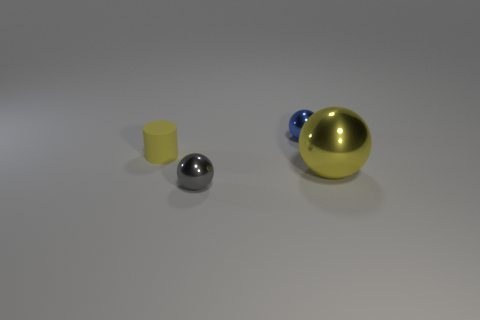Are there any other things that are the same shape as the large thing?
Offer a terse response. Yes. What is the color of the metallic thing that is to the right of the tiny thing to the right of the ball to the left of the tiny blue metal sphere?
Your answer should be very brief. Yellow. The object that is both left of the small blue sphere and behind the big yellow ball has what shape?
Your answer should be very brief. Cylinder. Are there any other things that have the same size as the blue object?
Keep it short and to the point. Yes. There is a metallic thing on the left side of the tiny metallic object that is behind the yellow ball; what is its color?
Your answer should be very brief. Gray. There is a yellow object on the left side of the small sphere that is behind the tiny metallic object in front of the tiny rubber cylinder; what shape is it?
Give a very brief answer. Cylinder. There is a metal thing that is behind the small gray thing and in front of the blue metallic sphere; how big is it?
Provide a succinct answer. Large. How many big metallic things have the same color as the small cylinder?
Your answer should be compact. 1. There is a big object that is the same color as the rubber cylinder; what is its material?
Ensure brevity in your answer.  Metal. What is the small gray ball made of?
Make the answer very short. Metal. 